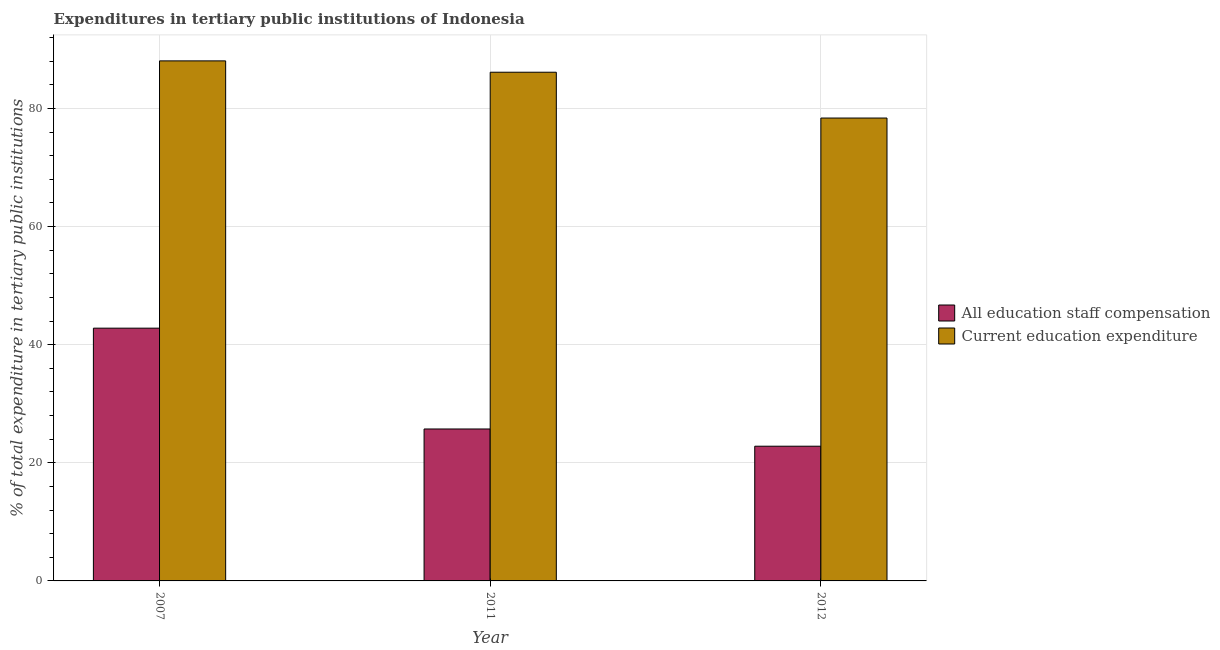How many different coloured bars are there?
Give a very brief answer. 2. Are the number of bars per tick equal to the number of legend labels?
Keep it short and to the point. Yes. What is the label of the 3rd group of bars from the left?
Keep it short and to the point. 2012. What is the expenditure in staff compensation in 2011?
Give a very brief answer. 25.72. Across all years, what is the maximum expenditure in staff compensation?
Keep it short and to the point. 42.79. Across all years, what is the minimum expenditure in staff compensation?
Give a very brief answer. 22.81. In which year was the expenditure in staff compensation maximum?
Keep it short and to the point. 2007. In which year was the expenditure in staff compensation minimum?
Keep it short and to the point. 2012. What is the total expenditure in education in the graph?
Provide a short and direct response. 252.53. What is the difference between the expenditure in staff compensation in 2007 and that in 2011?
Give a very brief answer. 17.07. What is the difference between the expenditure in staff compensation in 2012 and the expenditure in education in 2007?
Offer a terse response. -19.99. What is the average expenditure in staff compensation per year?
Provide a short and direct response. 30.44. In the year 2007, what is the difference between the expenditure in staff compensation and expenditure in education?
Offer a terse response. 0. In how many years, is the expenditure in education greater than 88 %?
Make the answer very short. 1. What is the ratio of the expenditure in staff compensation in 2011 to that in 2012?
Provide a short and direct response. 1.13. What is the difference between the highest and the second highest expenditure in education?
Make the answer very short. 1.92. What is the difference between the highest and the lowest expenditure in education?
Your answer should be compact. 9.68. What does the 1st bar from the left in 2012 represents?
Your answer should be compact. All education staff compensation. What does the 2nd bar from the right in 2012 represents?
Ensure brevity in your answer.  All education staff compensation. How many bars are there?
Ensure brevity in your answer.  6. Are all the bars in the graph horizontal?
Provide a short and direct response. No. How many years are there in the graph?
Your response must be concise. 3. What is the difference between two consecutive major ticks on the Y-axis?
Make the answer very short. 20. Are the values on the major ticks of Y-axis written in scientific E-notation?
Your response must be concise. No. Does the graph contain any zero values?
Ensure brevity in your answer.  No. Where does the legend appear in the graph?
Your answer should be compact. Center right. How are the legend labels stacked?
Ensure brevity in your answer.  Vertical. What is the title of the graph?
Offer a very short reply. Expenditures in tertiary public institutions of Indonesia. What is the label or title of the Y-axis?
Offer a terse response. % of total expenditure in tertiary public institutions. What is the % of total expenditure in tertiary public institutions of All education staff compensation in 2007?
Make the answer very short. 42.79. What is the % of total expenditure in tertiary public institutions of Current education expenditure in 2007?
Provide a short and direct response. 88.04. What is the % of total expenditure in tertiary public institutions of All education staff compensation in 2011?
Provide a succinct answer. 25.72. What is the % of total expenditure in tertiary public institutions of Current education expenditure in 2011?
Provide a succinct answer. 86.12. What is the % of total expenditure in tertiary public institutions in All education staff compensation in 2012?
Your answer should be compact. 22.81. What is the % of total expenditure in tertiary public institutions in Current education expenditure in 2012?
Ensure brevity in your answer.  78.37. Across all years, what is the maximum % of total expenditure in tertiary public institutions of All education staff compensation?
Your response must be concise. 42.79. Across all years, what is the maximum % of total expenditure in tertiary public institutions of Current education expenditure?
Provide a short and direct response. 88.04. Across all years, what is the minimum % of total expenditure in tertiary public institutions in All education staff compensation?
Your response must be concise. 22.81. Across all years, what is the minimum % of total expenditure in tertiary public institutions of Current education expenditure?
Provide a succinct answer. 78.37. What is the total % of total expenditure in tertiary public institutions of All education staff compensation in the graph?
Offer a very short reply. 91.32. What is the total % of total expenditure in tertiary public institutions in Current education expenditure in the graph?
Your answer should be very brief. 252.53. What is the difference between the % of total expenditure in tertiary public institutions in All education staff compensation in 2007 and that in 2011?
Offer a terse response. 17.07. What is the difference between the % of total expenditure in tertiary public institutions of Current education expenditure in 2007 and that in 2011?
Your response must be concise. 1.92. What is the difference between the % of total expenditure in tertiary public institutions of All education staff compensation in 2007 and that in 2012?
Your response must be concise. 19.99. What is the difference between the % of total expenditure in tertiary public institutions of Current education expenditure in 2007 and that in 2012?
Provide a short and direct response. 9.68. What is the difference between the % of total expenditure in tertiary public institutions of All education staff compensation in 2011 and that in 2012?
Offer a very short reply. 2.92. What is the difference between the % of total expenditure in tertiary public institutions in Current education expenditure in 2011 and that in 2012?
Offer a very short reply. 7.76. What is the difference between the % of total expenditure in tertiary public institutions in All education staff compensation in 2007 and the % of total expenditure in tertiary public institutions in Current education expenditure in 2011?
Offer a terse response. -43.33. What is the difference between the % of total expenditure in tertiary public institutions of All education staff compensation in 2007 and the % of total expenditure in tertiary public institutions of Current education expenditure in 2012?
Provide a short and direct response. -35.57. What is the difference between the % of total expenditure in tertiary public institutions in All education staff compensation in 2011 and the % of total expenditure in tertiary public institutions in Current education expenditure in 2012?
Offer a very short reply. -52.64. What is the average % of total expenditure in tertiary public institutions in All education staff compensation per year?
Offer a terse response. 30.44. What is the average % of total expenditure in tertiary public institutions in Current education expenditure per year?
Ensure brevity in your answer.  84.18. In the year 2007, what is the difference between the % of total expenditure in tertiary public institutions of All education staff compensation and % of total expenditure in tertiary public institutions of Current education expenditure?
Your answer should be compact. -45.25. In the year 2011, what is the difference between the % of total expenditure in tertiary public institutions in All education staff compensation and % of total expenditure in tertiary public institutions in Current education expenditure?
Give a very brief answer. -60.4. In the year 2012, what is the difference between the % of total expenditure in tertiary public institutions in All education staff compensation and % of total expenditure in tertiary public institutions in Current education expenditure?
Give a very brief answer. -55.56. What is the ratio of the % of total expenditure in tertiary public institutions in All education staff compensation in 2007 to that in 2011?
Your response must be concise. 1.66. What is the ratio of the % of total expenditure in tertiary public institutions in Current education expenditure in 2007 to that in 2011?
Ensure brevity in your answer.  1.02. What is the ratio of the % of total expenditure in tertiary public institutions in All education staff compensation in 2007 to that in 2012?
Provide a short and direct response. 1.88. What is the ratio of the % of total expenditure in tertiary public institutions in Current education expenditure in 2007 to that in 2012?
Keep it short and to the point. 1.12. What is the ratio of the % of total expenditure in tertiary public institutions in All education staff compensation in 2011 to that in 2012?
Give a very brief answer. 1.13. What is the ratio of the % of total expenditure in tertiary public institutions of Current education expenditure in 2011 to that in 2012?
Make the answer very short. 1.1. What is the difference between the highest and the second highest % of total expenditure in tertiary public institutions in All education staff compensation?
Keep it short and to the point. 17.07. What is the difference between the highest and the second highest % of total expenditure in tertiary public institutions of Current education expenditure?
Provide a short and direct response. 1.92. What is the difference between the highest and the lowest % of total expenditure in tertiary public institutions of All education staff compensation?
Your answer should be compact. 19.99. What is the difference between the highest and the lowest % of total expenditure in tertiary public institutions in Current education expenditure?
Your answer should be very brief. 9.68. 